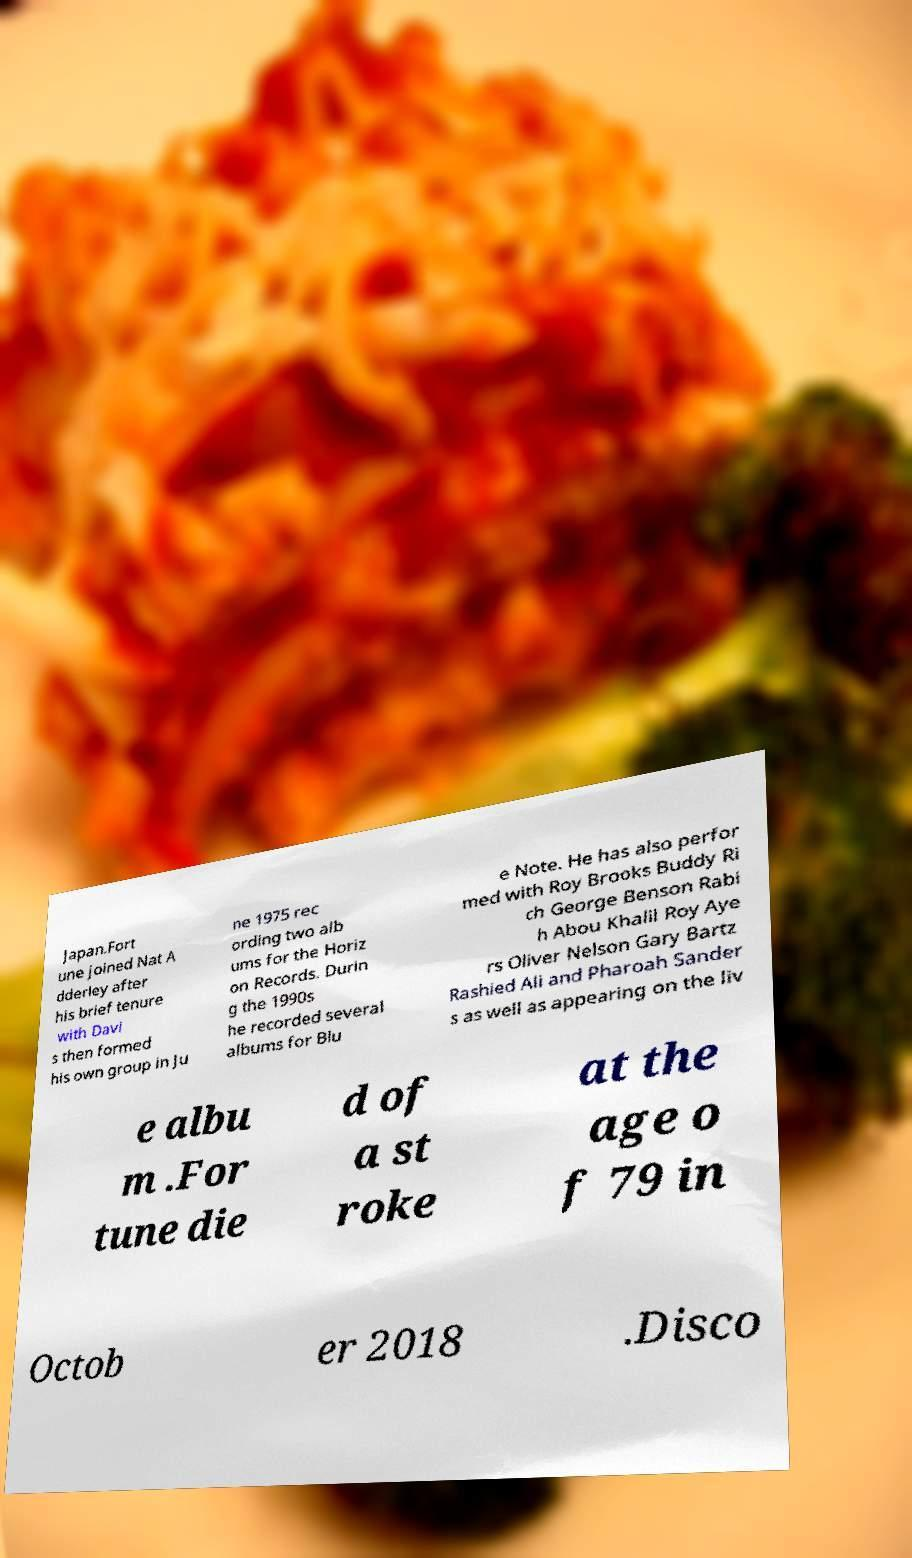Could you assist in decoding the text presented in this image and type it out clearly? Japan.Fort une joined Nat A dderley after his brief tenure with Davi s then formed his own group in Ju ne 1975 rec ording two alb ums for the Horiz on Records. Durin g the 1990s he recorded several albums for Blu e Note. He has also perfor med with Roy Brooks Buddy Ri ch George Benson Rabi h Abou Khalil Roy Aye rs Oliver Nelson Gary Bartz Rashied Ali and Pharoah Sander s as well as appearing on the liv e albu m .For tune die d of a st roke at the age o f 79 in Octob er 2018 .Disco 